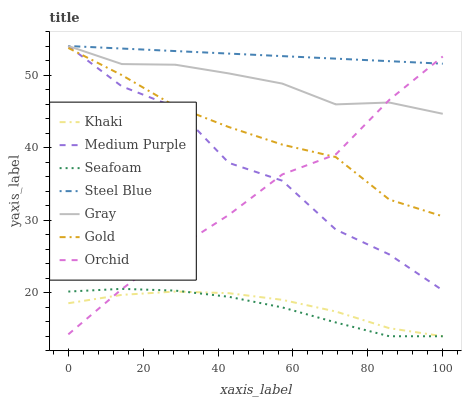Does Seafoam have the minimum area under the curve?
Answer yes or no. Yes. Does Steel Blue have the maximum area under the curve?
Answer yes or no. Yes. Does Khaki have the minimum area under the curve?
Answer yes or no. No. Does Khaki have the maximum area under the curve?
Answer yes or no. No. Is Steel Blue the smoothest?
Answer yes or no. Yes. Is Medium Purple the roughest?
Answer yes or no. Yes. Is Khaki the smoothest?
Answer yes or no. No. Is Khaki the roughest?
Answer yes or no. No. Does Khaki have the lowest value?
Answer yes or no. Yes. Does Gold have the lowest value?
Answer yes or no. No. Does Medium Purple have the highest value?
Answer yes or no. Yes. Does Gold have the highest value?
Answer yes or no. No. Is Gold less than Steel Blue?
Answer yes or no. Yes. Is Gold greater than Seafoam?
Answer yes or no. Yes. Does Steel Blue intersect Gray?
Answer yes or no. Yes. Is Steel Blue less than Gray?
Answer yes or no. No. Is Steel Blue greater than Gray?
Answer yes or no. No. Does Gold intersect Steel Blue?
Answer yes or no. No. 